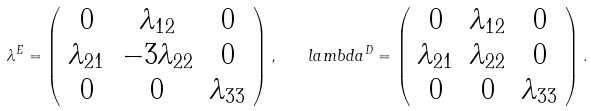<formula> <loc_0><loc_0><loc_500><loc_500>\lambda ^ { E } = \left ( \begin{array} { c c c } 0 & \lambda _ { 1 2 } & 0 \\ \lambda _ { 2 1 } & - 3 \lambda _ { 2 2 } & 0 \\ 0 & 0 & \lambda _ { 3 3 } \\ \end{array} \right ) , \ \ \ l a m b d a ^ { D } = \left ( \begin{array} { c c c } 0 & \lambda _ { 1 2 } & 0 \\ \lambda _ { 2 1 } & \lambda _ { 2 2 } & 0 \\ 0 & 0 & \lambda _ { 3 3 } \\ \end{array} \right ) .</formula> 